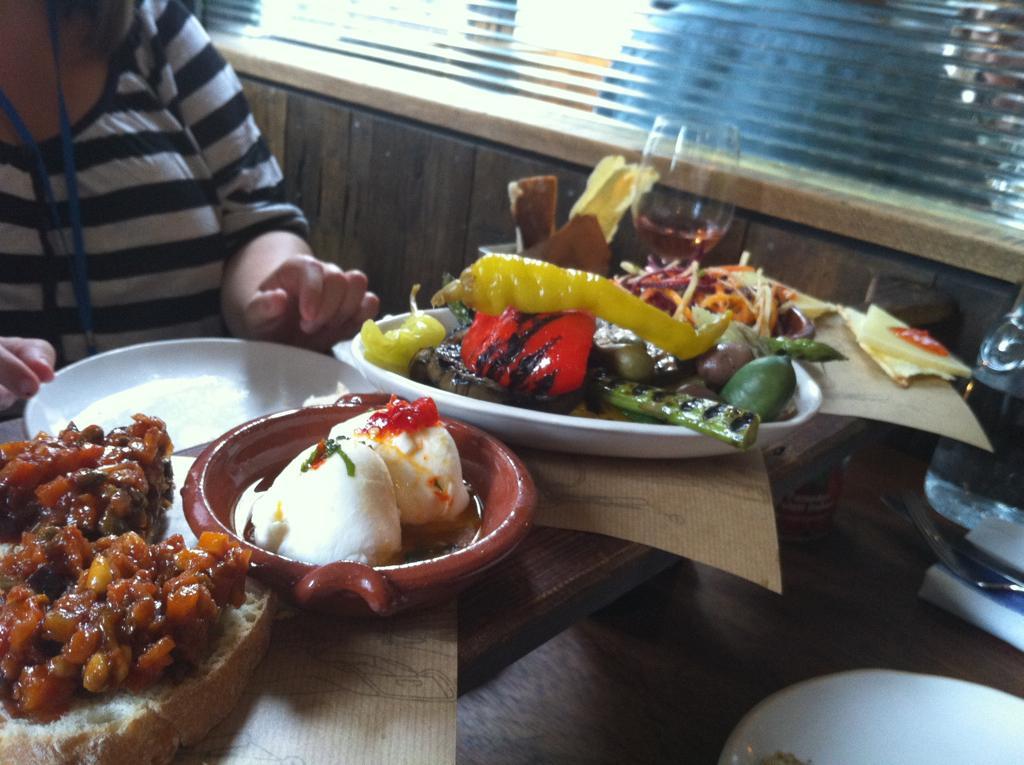Can you describe this image briefly? In this picture there are two persons sitting. There are food items on the plate. There are plates and there is a bowl, glass and bottle on the table. At the back there is a mirror. Behind the mirror there are two persons. 